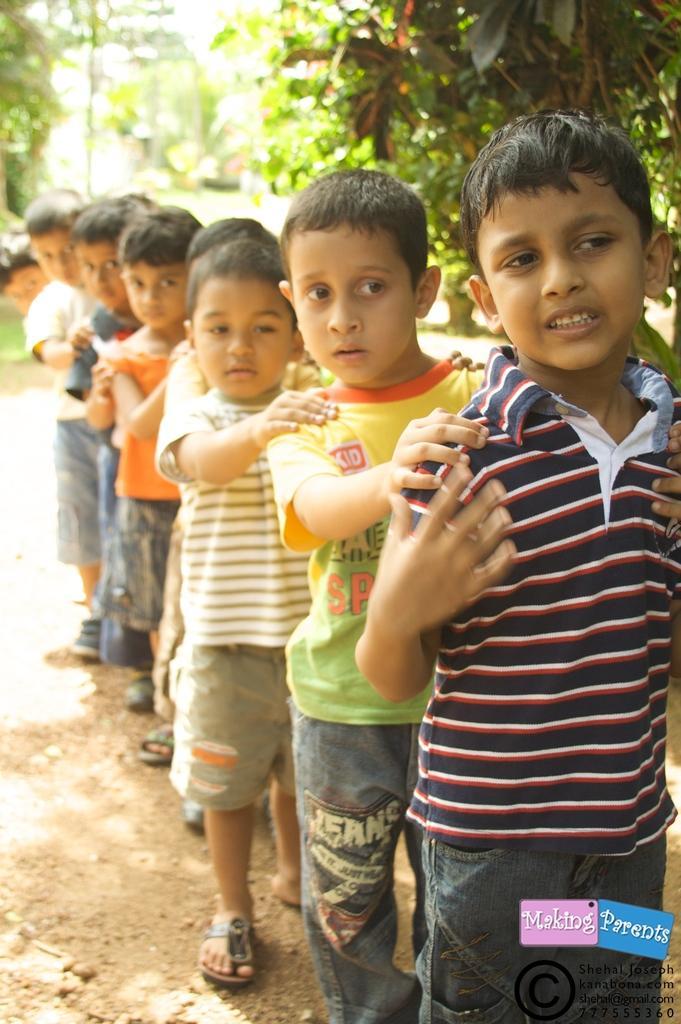Can you describe this image briefly? This picture consists of there are few boys standing in a line at the top there are some trees visible. 